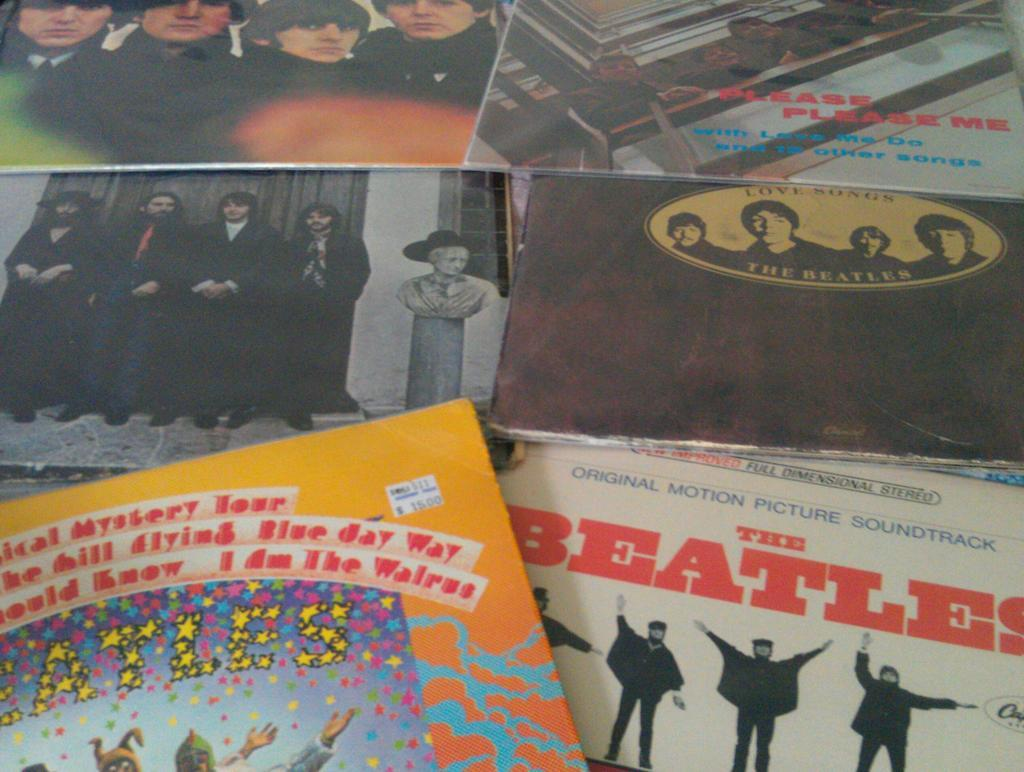<image>
Create a compact narrative representing the image presented. A collection of Beatles memorabilia includes the title Love Songs. 